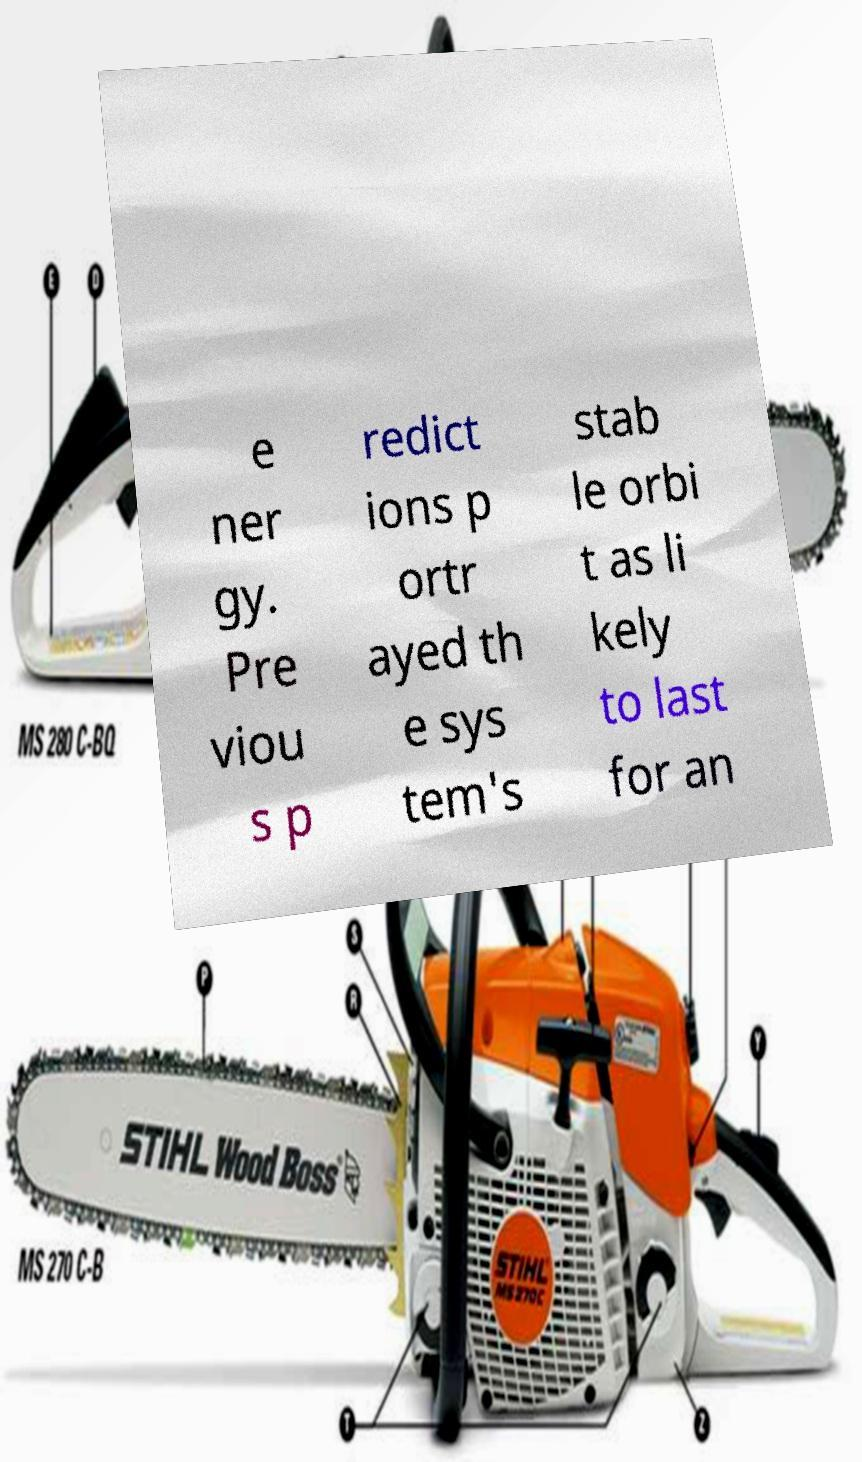Can you read and provide the text displayed in the image?This photo seems to have some interesting text. Can you extract and type it out for me? e ner gy. Pre viou s p redict ions p ortr ayed th e sys tem's stab le orbi t as li kely to last for an 